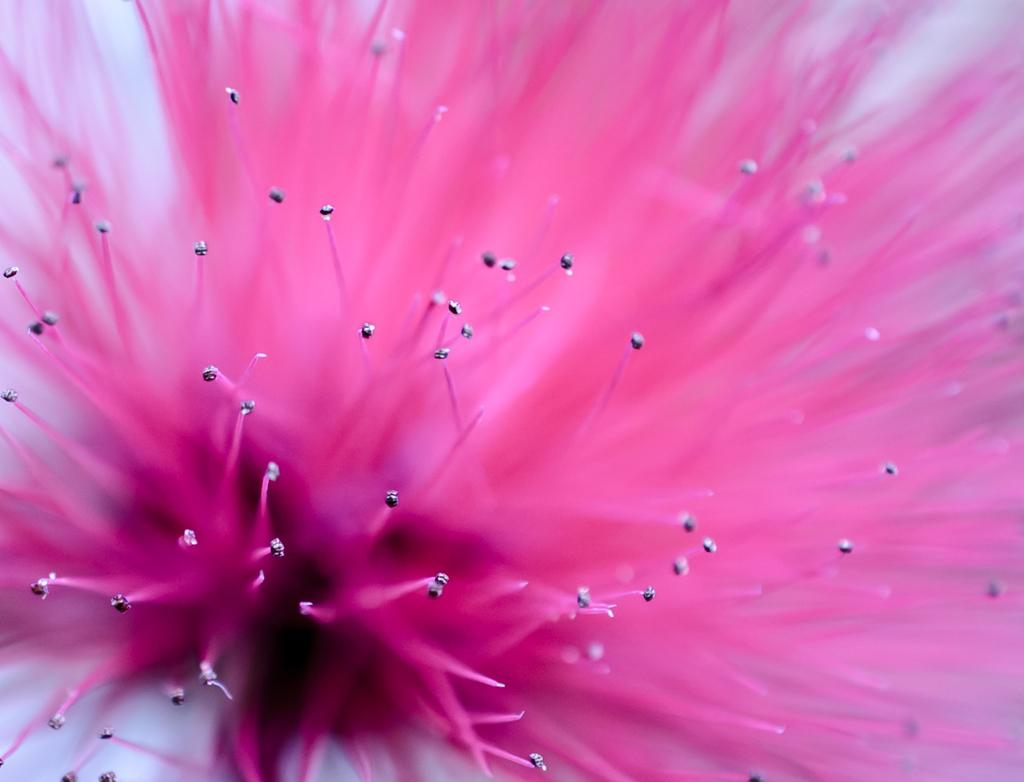What type of flower is present in the image? There is a pink flower in the image. How is the flower depicted in the image? The flower is truncated in the image. How far away is the stream from the flower in the image? There is no stream present in the image, so it is not possible to determine the distance between the flower and a stream. 